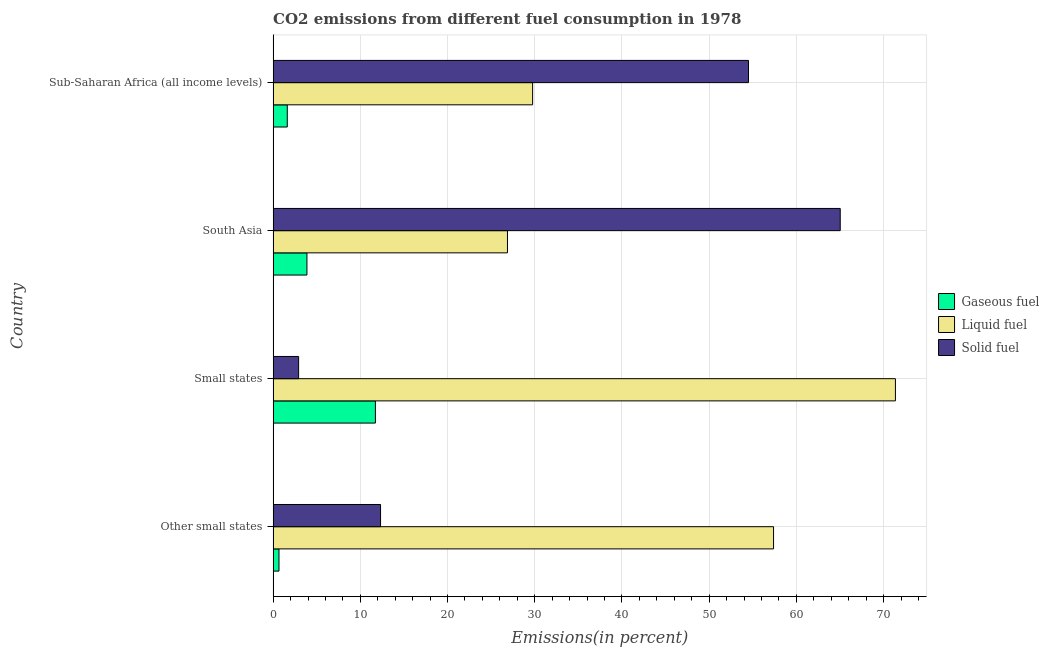How many different coloured bars are there?
Your response must be concise. 3. How many groups of bars are there?
Keep it short and to the point. 4. How many bars are there on the 3rd tick from the top?
Give a very brief answer. 3. What is the label of the 1st group of bars from the top?
Provide a succinct answer. Sub-Saharan Africa (all income levels). What is the percentage of solid fuel emission in Other small states?
Provide a succinct answer. 12.32. Across all countries, what is the maximum percentage of solid fuel emission?
Offer a very short reply. 65.03. Across all countries, what is the minimum percentage of gaseous fuel emission?
Your answer should be very brief. 0.67. In which country was the percentage of solid fuel emission minimum?
Your answer should be compact. Small states. What is the total percentage of gaseous fuel emission in the graph?
Your answer should be very brief. 17.9. What is the difference between the percentage of gaseous fuel emission in South Asia and that in Sub-Saharan Africa (all income levels)?
Offer a terse response. 2.25. What is the difference between the percentage of liquid fuel emission in South Asia and the percentage of gaseous fuel emission in Other small states?
Offer a very short reply. 26.2. What is the average percentage of solid fuel emission per country?
Offer a terse response. 33.69. What is the difference between the percentage of liquid fuel emission and percentage of solid fuel emission in Sub-Saharan Africa (all income levels)?
Your answer should be compact. -24.75. In how many countries, is the percentage of solid fuel emission greater than 42 %?
Make the answer very short. 2. What is the ratio of the percentage of solid fuel emission in Other small states to that in South Asia?
Your answer should be very brief. 0.19. Is the percentage of gaseous fuel emission in South Asia less than that in Sub-Saharan Africa (all income levels)?
Provide a short and direct response. No. What is the difference between the highest and the second highest percentage of liquid fuel emission?
Keep it short and to the point. 13.98. What is the difference between the highest and the lowest percentage of liquid fuel emission?
Your answer should be very brief. 44.49. In how many countries, is the percentage of liquid fuel emission greater than the average percentage of liquid fuel emission taken over all countries?
Your response must be concise. 2. Is the sum of the percentage of gaseous fuel emission in Other small states and Small states greater than the maximum percentage of liquid fuel emission across all countries?
Your answer should be compact. No. What does the 3rd bar from the top in Small states represents?
Provide a short and direct response. Gaseous fuel. What does the 3rd bar from the bottom in South Asia represents?
Give a very brief answer. Solid fuel. Is it the case that in every country, the sum of the percentage of gaseous fuel emission and percentage of liquid fuel emission is greater than the percentage of solid fuel emission?
Make the answer very short. No. How many bars are there?
Provide a succinct answer. 12. How many countries are there in the graph?
Offer a very short reply. 4. Are the values on the major ticks of X-axis written in scientific E-notation?
Keep it short and to the point. No. Does the graph contain any zero values?
Your response must be concise. No. Does the graph contain grids?
Make the answer very short. Yes. Where does the legend appear in the graph?
Make the answer very short. Center right. How many legend labels are there?
Your answer should be compact. 3. How are the legend labels stacked?
Ensure brevity in your answer.  Vertical. What is the title of the graph?
Keep it short and to the point. CO2 emissions from different fuel consumption in 1978. Does "Maunufacturing" appear as one of the legend labels in the graph?
Provide a short and direct response. No. What is the label or title of the X-axis?
Your answer should be compact. Emissions(in percent). What is the label or title of the Y-axis?
Your answer should be very brief. Country. What is the Emissions(in percent) in Gaseous fuel in Other small states?
Keep it short and to the point. 0.67. What is the Emissions(in percent) in Liquid fuel in Other small states?
Offer a very short reply. 57.38. What is the Emissions(in percent) in Solid fuel in Other small states?
Ensure brevity in your answer.  12.32. What is the Emissions(in percent) in Gaseous fuel in Small states?
Offer a terse response. 11.73. What is the Emissions(in percent) in Liquid fuel in Small states?
Your response must be concise. 71.36. What is the Emissions(in percent) in Solid fuel in Small states?
Your answer should be very brief. 2.92. What is the Emissions(in percent) in Gaseous fuel in South Asia?
Provide a short and direct response. 3.88. What is the Emissions(in percent) in Liquid fuel in South Asia?
Keep it short and to the point. 26.87. What is the Emissions(in percent) in Solid fuel in South Asia?
Make the answer very short. 65.03. What is the Emissions(in percent) of Gaseous fuel in Sub-Saharan Africa (all income levels)?
Offer a very short reply. 1.62. What is the Emissions(in percent) of Liquid fuel in Sub-Saharan Africa (all income levels)?
Provide a succinct answer. 29.75. What is the Emissions(in percent) of Solid fuel in Sub-Saharan Africa (all income levels)?
Provide a succinct answer. 54.51. Across all countries, what is the maximum Emissions(in percent) in Gaseous fuel?
Your answer should be very brief. 11.73. Across all countries, what is the maximum Emissions(in percent) of Liquid fuel?
Your answer should be very brief. 71.36. Across all countries, what is the maximum Emissions(in percent) of Solid fuel?
Make the answer very short. 65.03. Across all countries, what is the minimum Emissions(in percent) in Gaseous fuel?
Keep it short and to the point. 0.67. Across all countries, what is the minimum Emissions(in percent) of Liquid fuel?
Offer a very short reply. 26.87. Across all countries, what is the minimum Emissions(in percent) of Solid fuel?
Provide a succinct answer. 2.92. What is the total Emissions(in percent) in Gaseous fuel in the graph?
Provide a succinct answer. 17.9. What is the total Emissions(in percent) in Liquid fuel in the graph?
Your response must be concise. 185.36. What is the total Emissions(in percent) in Solid fuel in the graph?
Offer a very short reply. 134.78. What is the difference between the Emissions(in percent) in Gaseous fuel in Other small states and that in Small states?
Offer a terse response. -11.06. What is the difference between the Emissions(in percent) of Liquid fuel in Other small states and that in Small states?
Give a very brief answer. -13.98. What is the difference between the Emissions(in percent) in Solid fuel in Other small states and that in Small states?
Provide a short and direct response. 9.4. What is the difference between the Emissions(in percent) of Gaseous fuel in Other small states and that in South Asia?
Your response must be concise. -3.2. What is the difference between the Emissions(in percent) in Liquid fuel in Other small states and that in South Asia?
Your response must be concise. 30.51. What is the difference between the Emissions(in percent) of Solid fuel in Other small states and that in South Asia?
Give a very brief answer. -52.71. What is the difference between the Emissions(in percent) in Gaseous fuel in Other small states and that in Sub-Saharan Africa (all income levels)?
Keep it short and to the point. -0.95. What is the difference between the Emissions(in percent) in Liquid fuel in Other small states and that in Sub-Saharan Africa (all income levels)?
Your answer should be compact. 27.63. What is the difference between the Emissions(in percent) in Solid fuel in Other small states and that in Sub-Saharan Africa (all income levels)?
Ensure brevity in your answer.  -42.19. What is the difference between the Emissions(in percent) in Gaseous fuel in Small states and that in South Asia?
Offer a terse response. 7.85. What is the difference between the Emissions(in percent) of Liquid fuel in Small states and that in South Asia?
Ensure brevity in your answer.  44.49. What is the difference between the Emissions(in percent) of Solid fuel in Small states and that in South Asia?
Your answer should be compact. -62.1. What is the difference between the Emissions(in percent) of Gaseous fuel in Small states and that in Sub-Saharan Africa (all income levels)?
Make the answer very short. 10.1. What is the difference between the Emissions(in percent) of Liquid fuel in Small states and that in Sub-Saharan Africa (all income levels)?
Your answer should be compact. 41.6. What is the difference between the Emissions(in percent) of Solid fuel in Small states and that in Sub-Saharan Africa (all income levels)?
Keep it short and to the point. -51.59. What is the difference between the Emissions(in percent) in Gaseous fuel in South Asia and that in Sub-Saharan Africa (all income levels)?
Offer a terse response. 2.25. What is the difference between the Emissions(in percent) in Liquid fuel in South Asia and that in Sub-Saharan Africa (all income levels)?
Your answer should be very brief. -2.88. What is the difference between the Emissions(in percent) in Solid fuel in South Asia and that in Sub-Saharan Africa (all income levels)?
Make the answer very short. 10.52. What is the difference between the Emissions(in percent) of Gaseous fuel in Other small states and the Emissions(in percent) of Liquid fuel in Small states?
Ensure brevity in your answer.  -70.68. What is the difference between the Emissions(in percent) of Gaseous fuel in Other small states and the Emissions(in percent) of Solid fuel in Small states?
Your answer should be compact. -2.25. What is the difference between the Emissions(in percent) of Liquid fuel in Other small states and the Emissions(in percent) of Solid fuel in Small states?
Ensure brevity in your answer.  54.46. What is the difference between the Emissions(in percent) in Gaseous fuel in Other small states and the Emissions(in percent) in Liquid fuel in South Asia?
Provide a succinct answer. -26.2. What is the difference between the Emissions(in percent) of Gaseous fuel in Other small states and the Emissions(in percent) of Solid fuel in South Asia?
Your answer should be very brief. -64.35. What is the difference between the Emissions(in percent) in Liquid fuel in Other small states and the Emissions(in percent) in Solid fuel in South Asia?
Your answer should be compact. -7.65. What is the difference between the Emissions(in percent) in Gaseous fuel in Other small states and the Emissions(in percent) in Liquid fuel in Sub-Saharan Africa (all income levels)?
Make the answer very short. -29.08. What is the difference between the Emissions(in percent) of Gaseous fuel in Other small states and the Emissions(in percent) of Solid fuel in Sub-Saharan Africa (all income levels)?
Keep it short and to the point. -53.84. What is the difference between the Emissions(in percent) of Liquid fuel in Other small states and the Emissions(in percent) of Solid fuel in Sub-Saharan Africa (all income levels)?
Give a very brief answer. 2.87. What is the difference between the Emissions(in percent) in Gaseous fuel in Small states and the Emissions(in percent) in Liquid fuel in South Asia?
Provide a short and direct response. -15.14. What is the difference between the Emissions(in percent) of Gaseous fuel in Small states and the Emissions(in percent) of Solid fuel in South Asia?
Your response must be concise. -53.3. What is the difference between the Emissions(in percent) of Liquid fuel in Small states and the Emissions(in percent) of Solid fuel in South Asia?
Offer a very short reply. 6.33. What is the difference between the Emissions(in percent) in Gaseous fuel in Small states and the Emissions(in percent) in Liquid fuel in Sub-Saharan Africa (all income levels)?
Offer a very short reply. -18.03. What is the difference between the Emissions(in percent) of Gaseous fuel in Small states and the Emissions(in percent) of Solid fuel in Sub-Saharan Africa (all income levels)?
Keep it short and to the point. -42.78. What is the difference between the Emissions(in percent) in Liquid fuel in Small states and the Emissions(in percent) in Solid fuel in Sub-Saharan Africa (all income levels)?
Your answer should be very brief. 16.85. What is the difference between the Emissions(in percent) of Gaseous fuel in South Asia and the Emissions(in percent) of Liquid fuel in Sub-Saharan Africa (all income levels)?
Your answer should be compact. -25.88. What is the difference between the Emissions(in percent) of Gaseous fuel in South Asia and the Emissions(in percent) of Solid fuel in Sub-Saharan Africa (all income levels)?
Make the answer very short. -50.63. What is the difference between the Emissions(in percent) in Liquid fuel in South Asia and the Emissions(in percent) in Solid fuel in Sub-Saharan Africa (all income levels)?
Ensure brevity in your answer.  -27.64. What is the average Emissions(in percent) of Gaseous fuel per country?
Ensure brevity in your answer.  4.48. What is the average Emissions(in percent) of Liquid fuel per country?
Give a very brief answer. 46.34. What is the average Emissions(in percent) of Solid fuel per country?
Your answer should be very brief. 33.69. What is the difference between the Emissions(in percent) in Gaseous fuel and Emissions(in percent) in Liquid fuel in Other small states?
Provide a short and direct response. -56.71. What is the difference between the Emissions(in percent) of Gaseous fuel and Emissions(in percent) of Solid fuel in Other small states?
Make the answer very short. -11.65. What is the difference between the Emissions(in percent) in Liquid fuel and Emissions(in percent) in Solid fuel in Other small states?
Make the answer very short. 45.06. What is the difference between the Emissions(in percent) in Gaseous fuel and Emissions(in percent) in Liquid fuel in Small states?
Offer a terse response. -59.63. What is the difference between the Emissions(in percent) of Gaseous fuel and Emissions(in percent) of Solid fuel in Small states?
Offer a very short reply. 8.81. What is the difference between the Emissions(in percent) of Liquid fuel and Emissions(in percent) of Solid fuel in Small states?
Offer a terse response. 68.43. What is the difference between the Emissions(in percent) in Gaseous fuel and Emissions(in percent) in Liquid fuel in South Asia?
Your response must be concise. -22.99. What is the difference between the Emissions(in percent) in Gaseous fuel and Emissions(in percent) in Solid fuel in South Asia?
Provide a succinct answer. -61.15. What is the difference between the Emissions(in percent) in Liquid fuel and Emissions(in percent) in Solid fuel in South Asia?
Ensure brevity in your answer.  -38.16. What is the difference between the Emissions(in percent) in Gaseous fuel and Emissions(in percent) in Liquid fuel in Sub-Saharan Africa (all income levels)?
Offer a terse response. -28.13. What is the difference between the Emissions(in percent) of Gaseous fuel and Emissions(in percent) of Solid fuel in Sub-Saharan Africa (all income levels)?
Keep it short and to the point. -52.89. What is the difference between the Emissions(in percent) in Liquid fuel and Emissions(in percent) in Solid fuel in Sub-Saharan Africa (all income levels)?
Provide a succinct answer. -24.75. What is the ratio of the Emissions(in percent) of Gaseous fuel in Other small states to that in Small states?
Your answer should be very brief. 0.06. What is the ratio of the Emissions(in percent) in Liquid fuel in Other small states to that in Small states?
Keep it short and to the point. 0.8. What is the ratio of the Emissions(in percent) in Solid fuel in Other small states to that in Small states?
Make the answer very short. 4.22. What is the ratio of the Emissions(in percent) in Gaseous fuel in Other small states to that in South Asia?
Give a very brief answer. 0.17. What is the ratio of the Emissions(in percent) of Liquid fuel in Other small states to that in South Asia?
Offer a terse response. 2.14. What is the ratio of the Emissions(in percent) of Solid fuel in Other small states to that in South Asia?
Offer a very short reply. 0.19. What is the ratio of the Emissions(in percent) in Gaseous fuel in Other small states to that in Sub-Saharan Africa (all income levels)?
Your answer should be compact. 0.41. What is the ratio of the Emissions(in percent) in Liquid fuel in Other small states to that in Sub-Saharan Africa (all income levels)?
Your answer should be very brief. 1.93. What is the ratio of the Emissions(in percent) in Solid fuel in Other small states to that in Sub-Saharan Africa (all income levels)?
Provide a succinct answer. 0.23. What is the ratio of the Emissions(in percent) in Gaseous fuel in Small states to that in South Asia?
Offer a very short reply. 3.02. What is the ratio of the Emissions(in percent) in Liquid fuel in Small states to that in South Asia?
Provide a succinct answer. 2.66. What is the ratio of the Emissions(in percent) of Solid fuel in Small states to that in South Asia?
Provide a short and direct response. 0.04. What is the ratio of the Emissions(in percent) of Gaseous fuel in Small states to that in Sub-Saharan Africa (all income levels)?
Your answer should be compact. 7.22. What is the ratio of the Emissions(in percent) of Liquid fuel in Small states to that in Sub-Saharan Africa (all income levels)?
Provide a short and direct response. 2.4. What is the ratio of the Emissions(in percent) in Solid fuel in Small states to that in Sub-Saharan Africa (all income levels)?
Provide a succinct answer. 0.05. What is the ratio of the Emissions(in percent) in Gaseous fuel in South Asia to that in Sub-Saharan Africa (all income levels)?
Your answer should be compact. 2.39. What is the ratio of the Emissions(in percent) in Liquid fuel in South Asia to that in Sub-Saharan Africa (all income levels)?
Provide a short and direct response. 0.9. What is the ratio of the Emissions(in percent) in Solid fuel in South Asia to that in Sub-Saharan Africa (all income levels)?
Your answer should be very brief. 1.19. What is the difference between the highest and the second highest Emissions(in percent) of Gaseous fuel?
Your answer should be very brief. 7.85. What is the difference between the highest and the second highest Emissions(in percent) in Liquid fuel?
Give a very brief answer. 13.98. What is the difference between the highest and the second highest Emissions(in percent) of Solid fuel?
Keep it short and to the point. 10.52. What is the difference between the highest and the lowest Emissions(in percent) of Gaseous fuel?
Make the answer very short. 11.06. What is the difference between the highest and the lowest Emissions(in percent) in Liquid fuel?
Your answer should be compact. 44.49. What is the difference between the highest and the lowest Emissions(in percent) of Solid fuel?
Your answer should be compact. 62.1. 